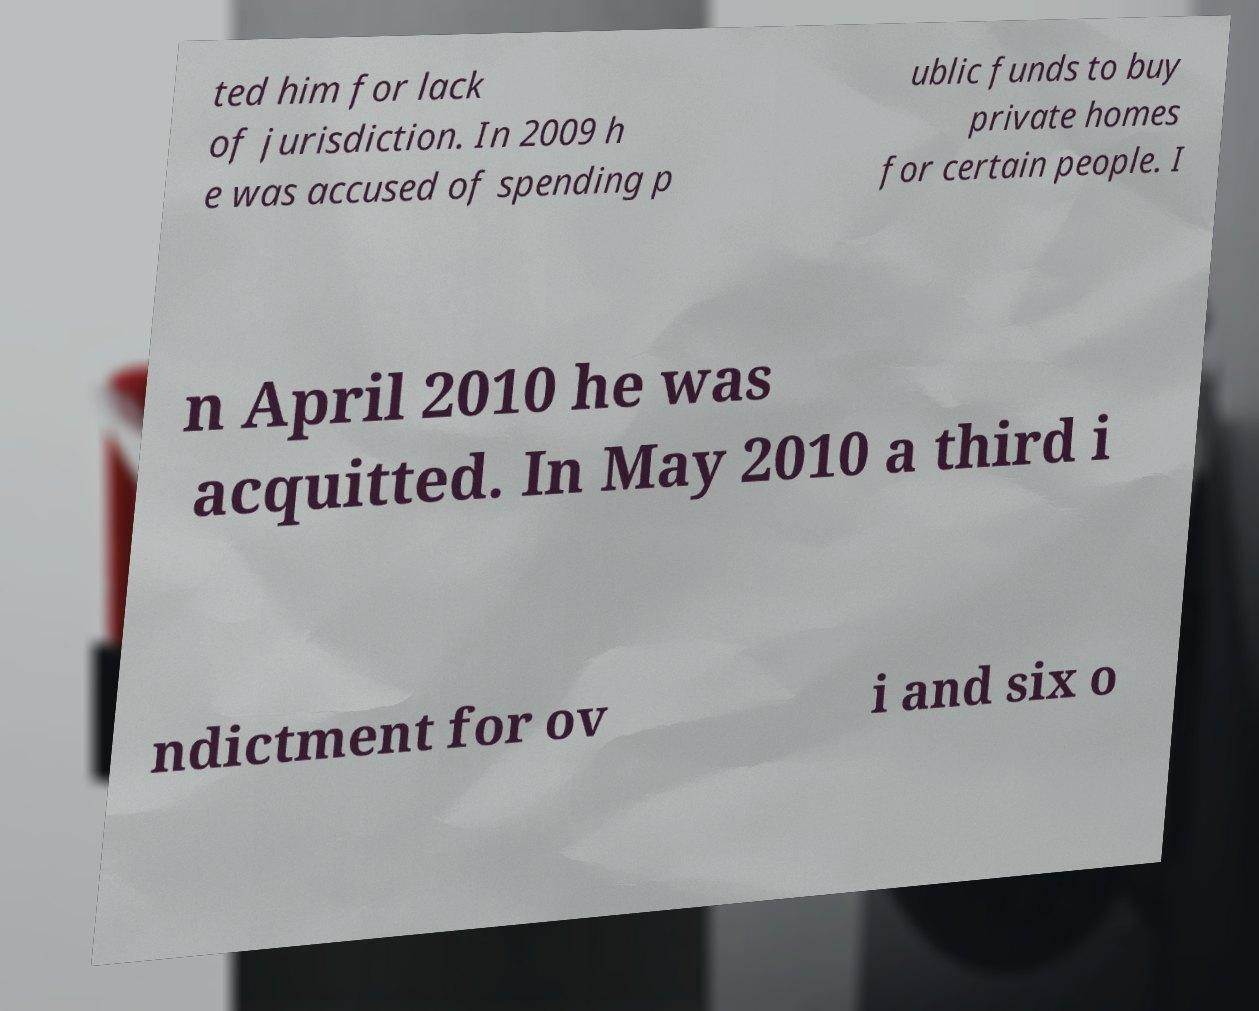I need the written content from this picture converted into text. Can you do that? ted him for lack of jurisdiction. In 2009 h e was accused of spending p ublic funds to buy private homes for certain people. I n April 2010 he was acquitted. In May 2010 a third i ndictment for ov i and six o 